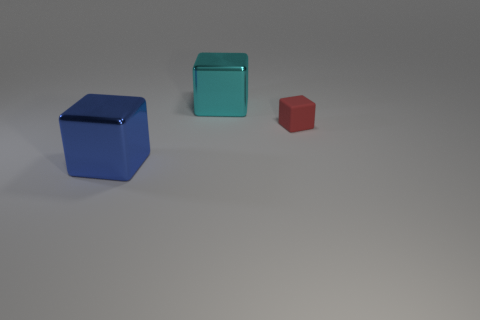Subtract all large cubes. How many cubes are left? 1 Add 1 large green metallic cylinders. How many objects exist? 4 Subtract all red blocks. How many blocks are left? 2 Subtract all yellow cubes. Subtract all green spheres. How many cubes are left? 3 Subtract all green cylinders. How many red blocks are left? 1 Add 1 red matte blocks. How many red matte blocks are left? 2 Add 1 blue objects. How many blue objects exist? 2 Subtract 1 red blocks. How many objects are left? 2 Subtract 3 cubes. How many cubes are left? 0 Subtract all big blue blocks. Subtract all matte blocks. How many objects are left? 1 